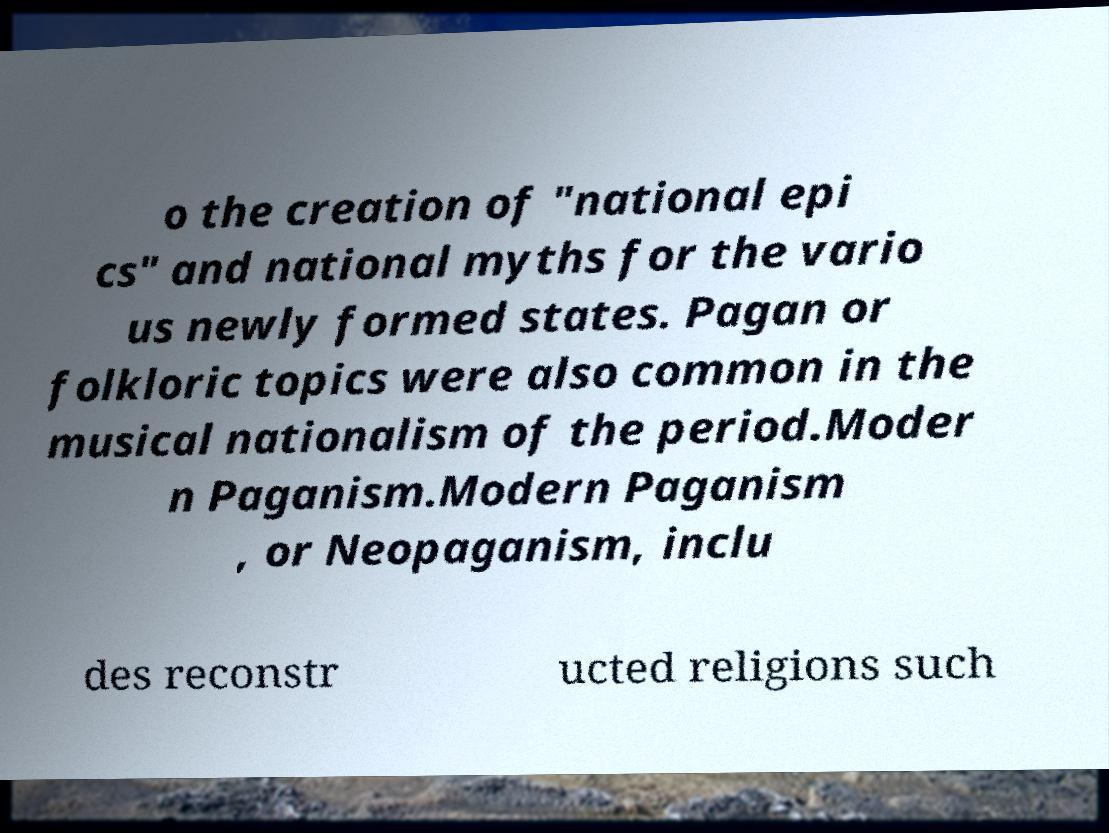I need the written content from this picture converted into text. Can you do that? o the creation of "national epi cs" and national myths for the vario us newly formed states. Pagan or folkloric topics were also common in the musical nationalism of the period.Moder n Paganism.Modern Paganism , or Neopaganism, inclu des reconstr ucted religions such 